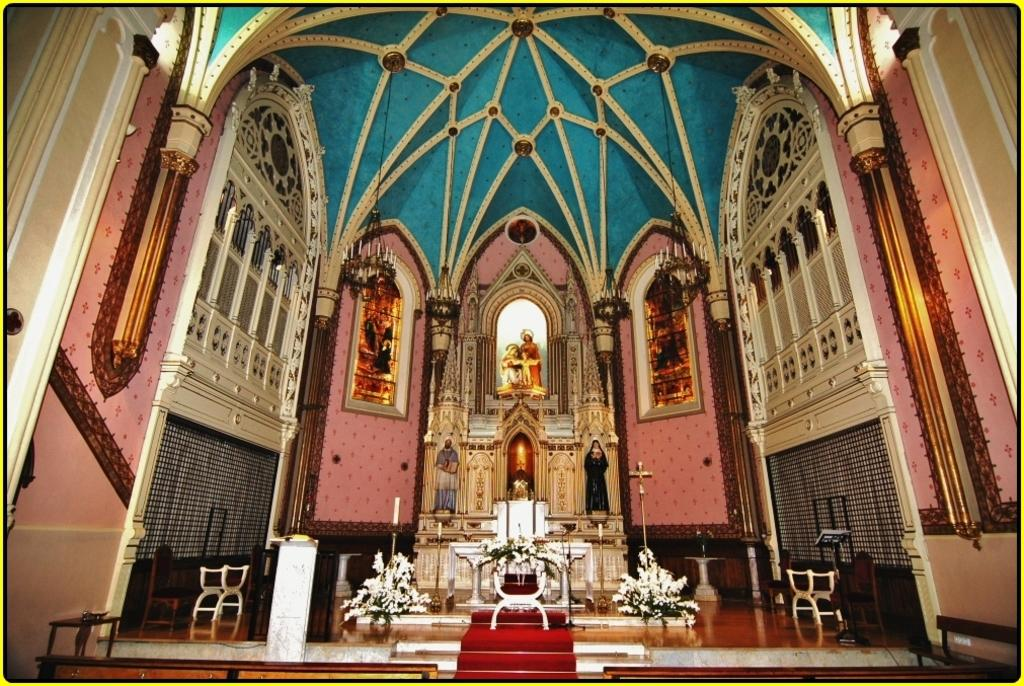What is located in the foreground of the image? In the foreground of the image, there are stairs, a carpet, chairs, candles, flower vases, windows, sculptures on the wall, and chandeliers. Can you describe the type of flooring in the foreground? The flooring in the foreground is a carpet. What architectural feature is present at the top of the image? There is an inside roof of a dome at the top of the image. Who is the expert in charge of the operation depicted in the image? There is no operation or expert present in the image; it features a room with various decorative elements and architectural features. How does the image show respect for the cultural heritage of the depicted location? The image itself does not convey respect or cultural heritage; it is a visual representation of a room with various decorative elements and architectural features. 